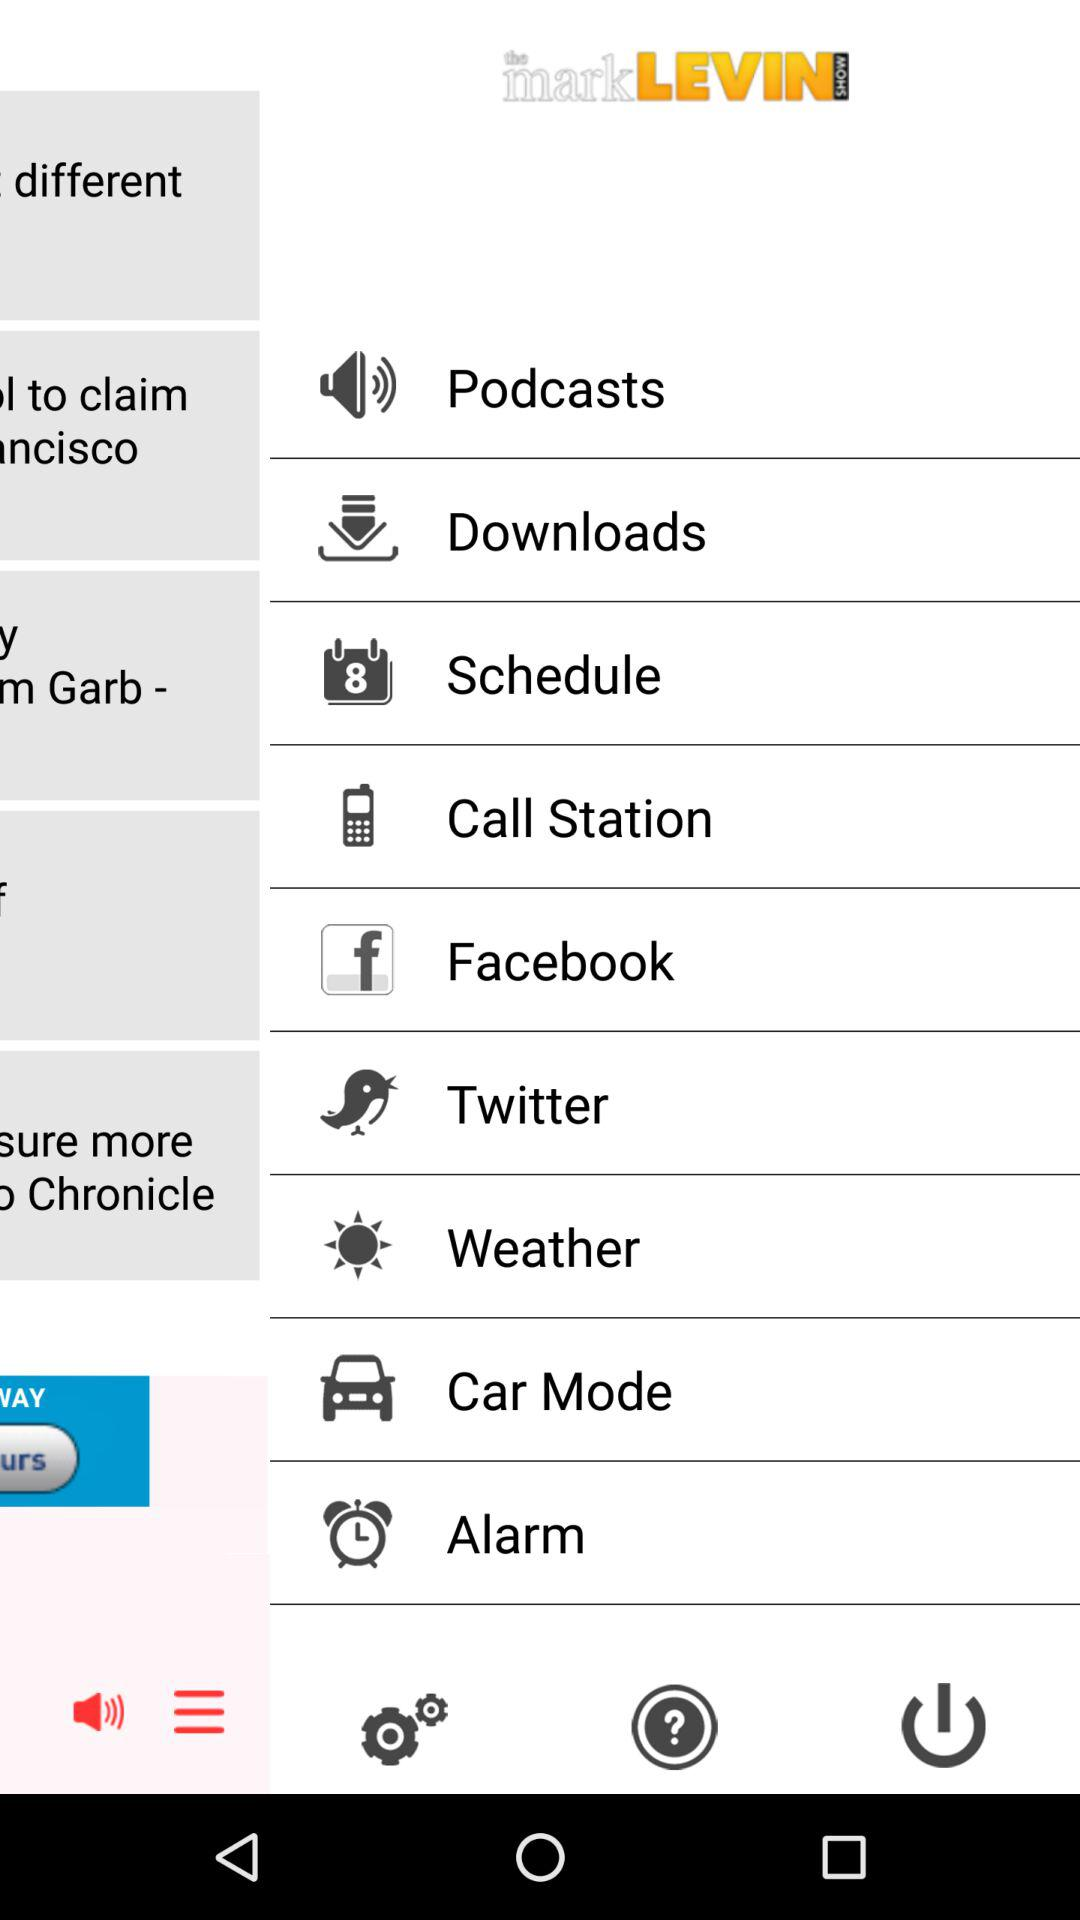What is the application name? The application name is "the markLEVIN SHOW". 